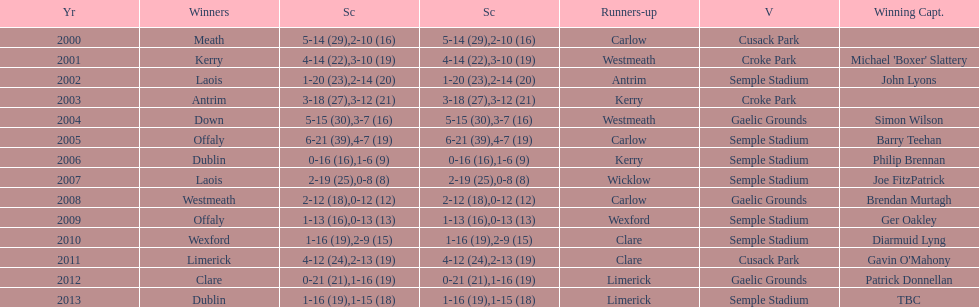Who scored the least? Wicklow. 